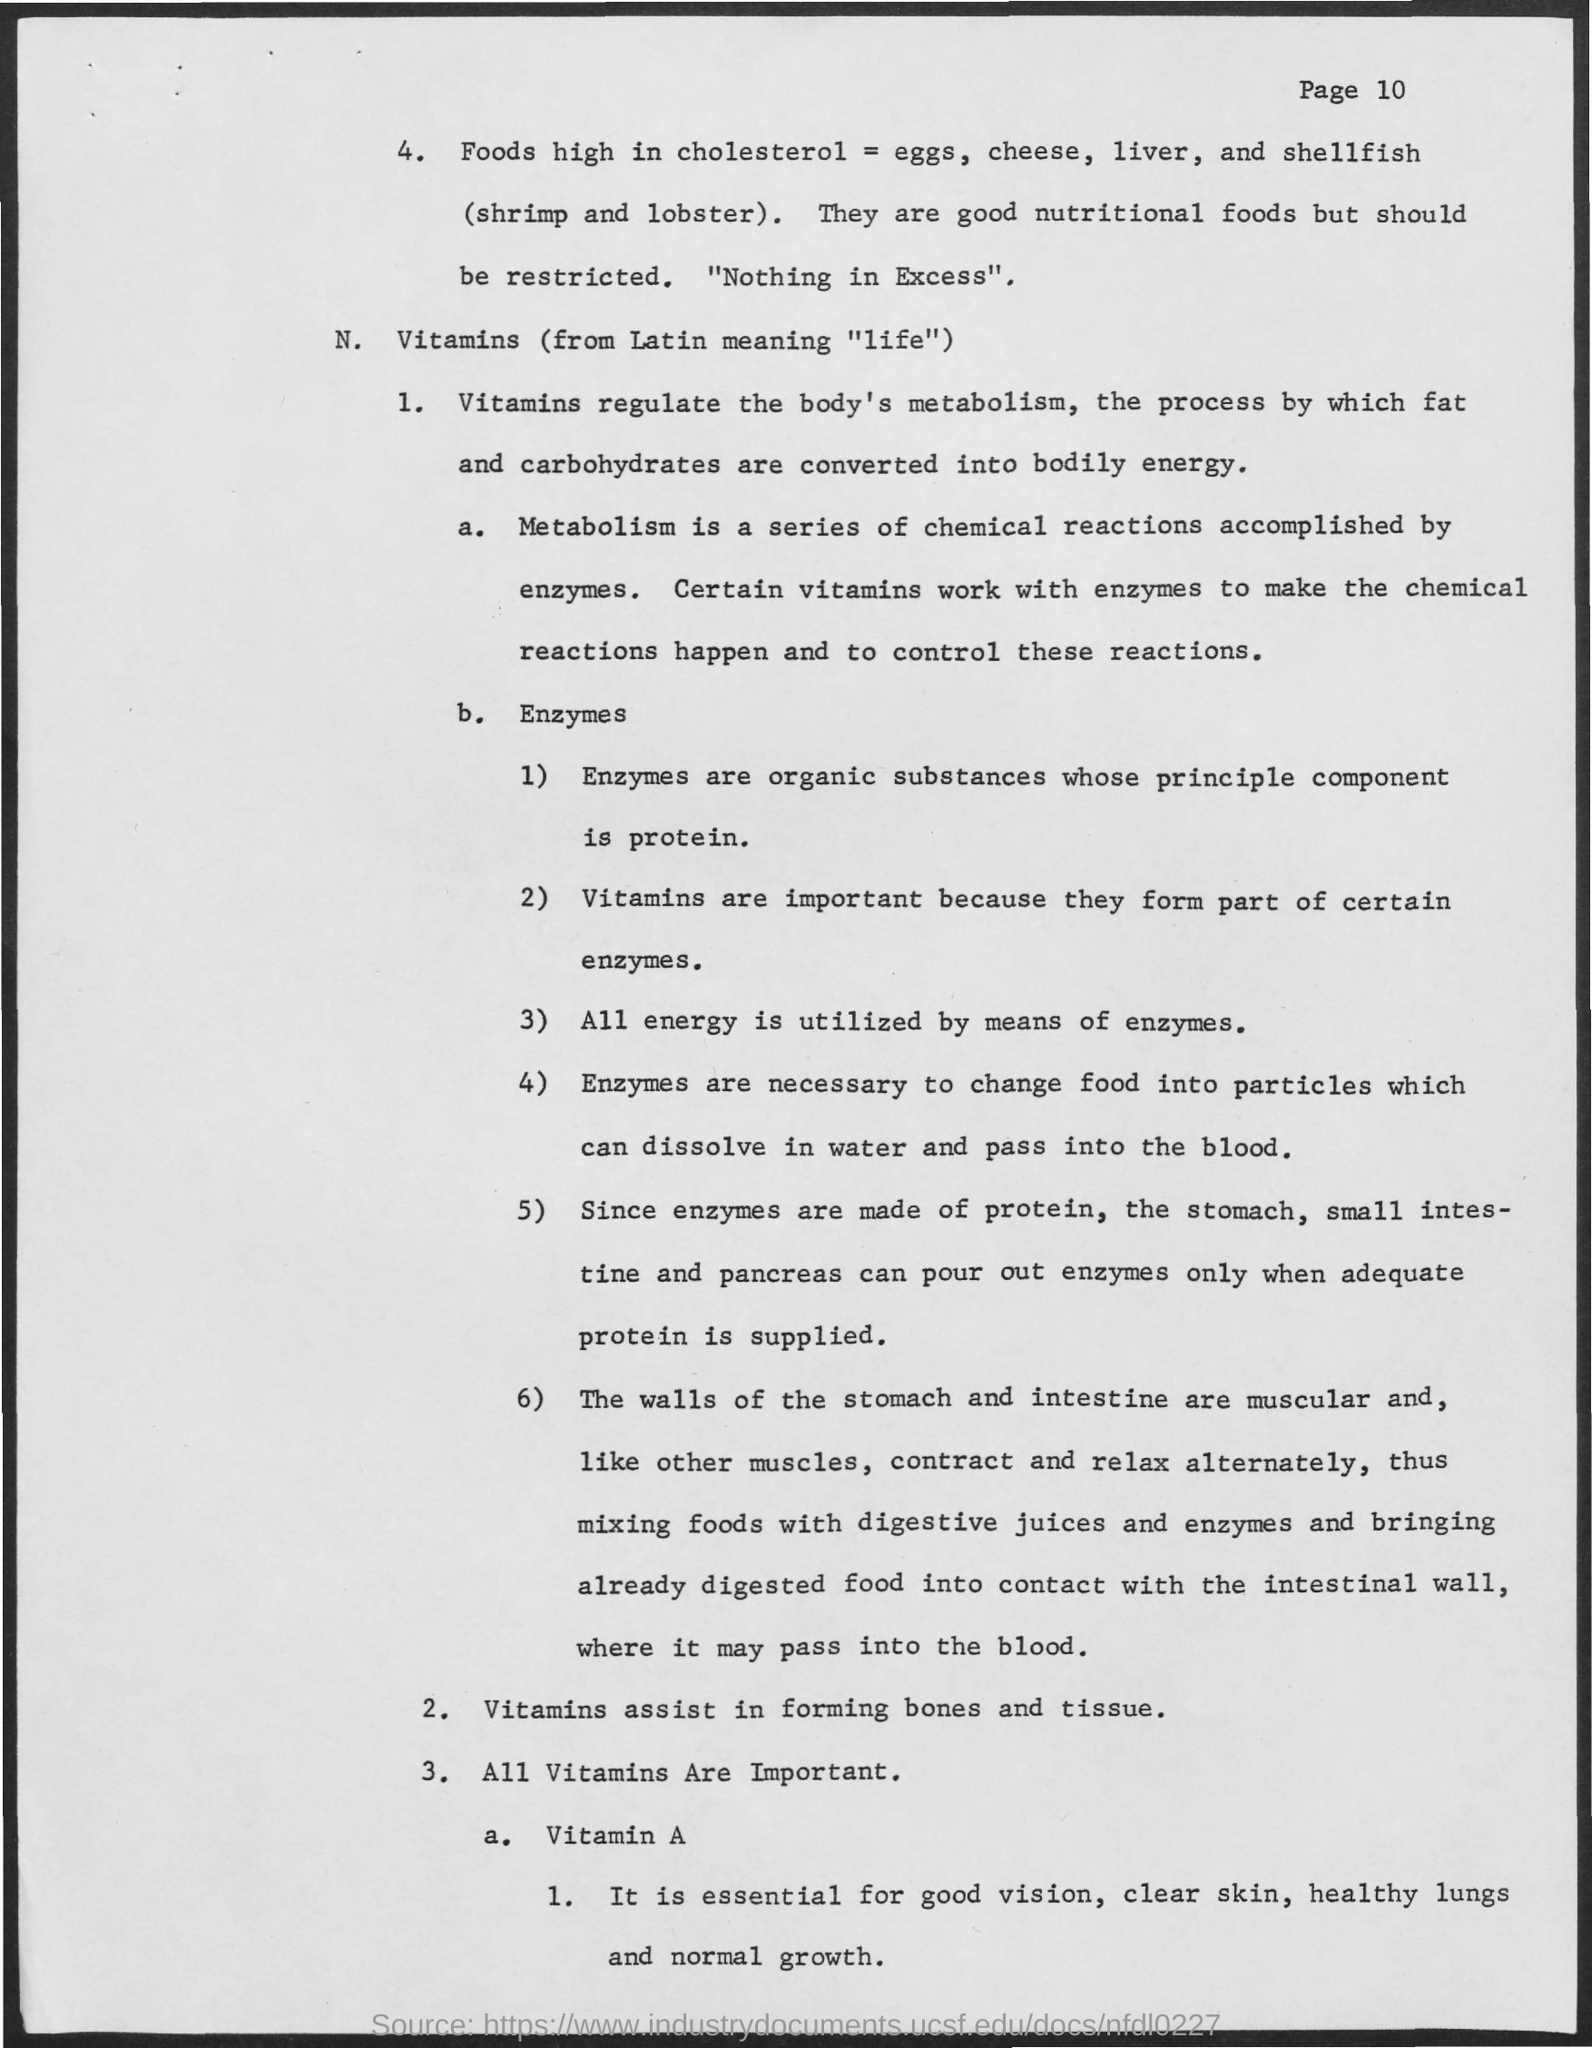Outline some significant characteristics in this image. The process by which fats and carbohydrates are converted into energy is metabolism. Vitamins are required for assisting in the formation of bone and tissue. 